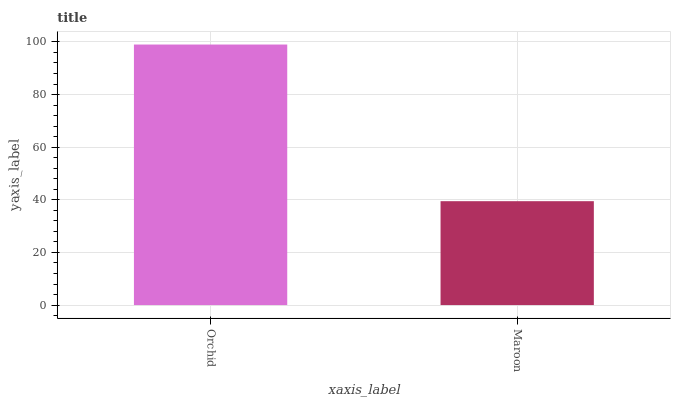Is Maroon the maximum?
Answer yes or no. No. Is Orchid greater than Maroon?
Answer yes or no. Yes. Is Maroon less than Orchid?
Answer yes or no. Yes. Is Maroon greater than Orchid?
Answer yes or no. No. Is Orchid less than Maroon?
Answer yes or no. No. Is Orchid the high median?
Answer yes or no. Yes. Is Maroon the low median?
Answer yes or no. Yes. Is Maroon the high median?
Answer yes or no. No. Is Orchid the low median?
Answer yes or no. No. 